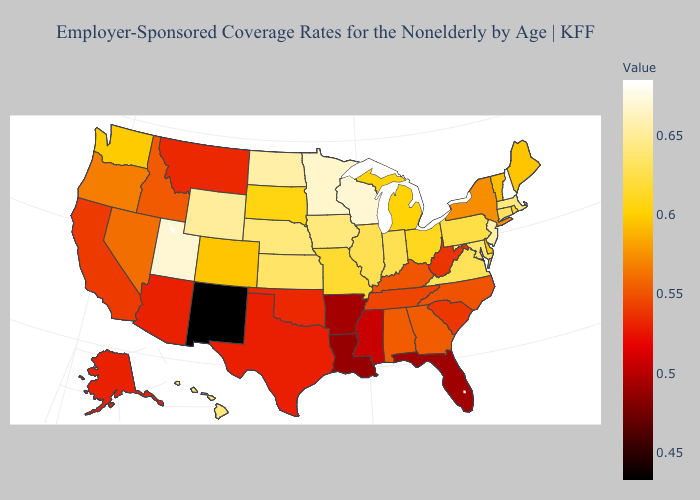Does Texas have a lower value than Arkansas?
Give a very brief answer. No. Does Maryland have the highest value in the South?
Write a very short answer. Yes. Among the states that border Delaware , which have the lowest value?
Give a very brief answer. Pennsylvania. Does Missouri have a lower value than New Jersey?
Give a very brief answer. Yes. Among the states that border Maryland , does Pennsylvania have the lowest value?
Answer briefly. No. Among the states that border Oklahoma , which have the highest value?
Write a very short answer. Kansas. Does New Mexico have the lowest value in the West?
Give a very brief answer. Yes. 